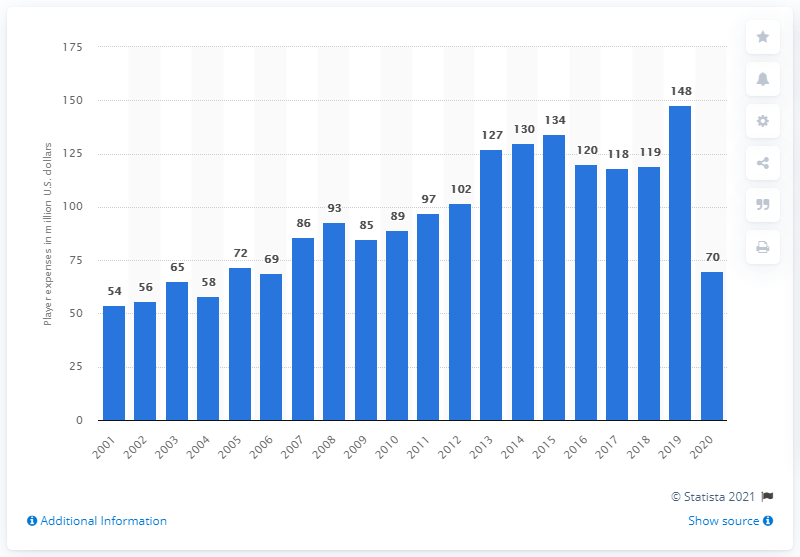Identify some key points in this picture. The payroll of the Cincinnati Reds in 2020 was $70 million. 